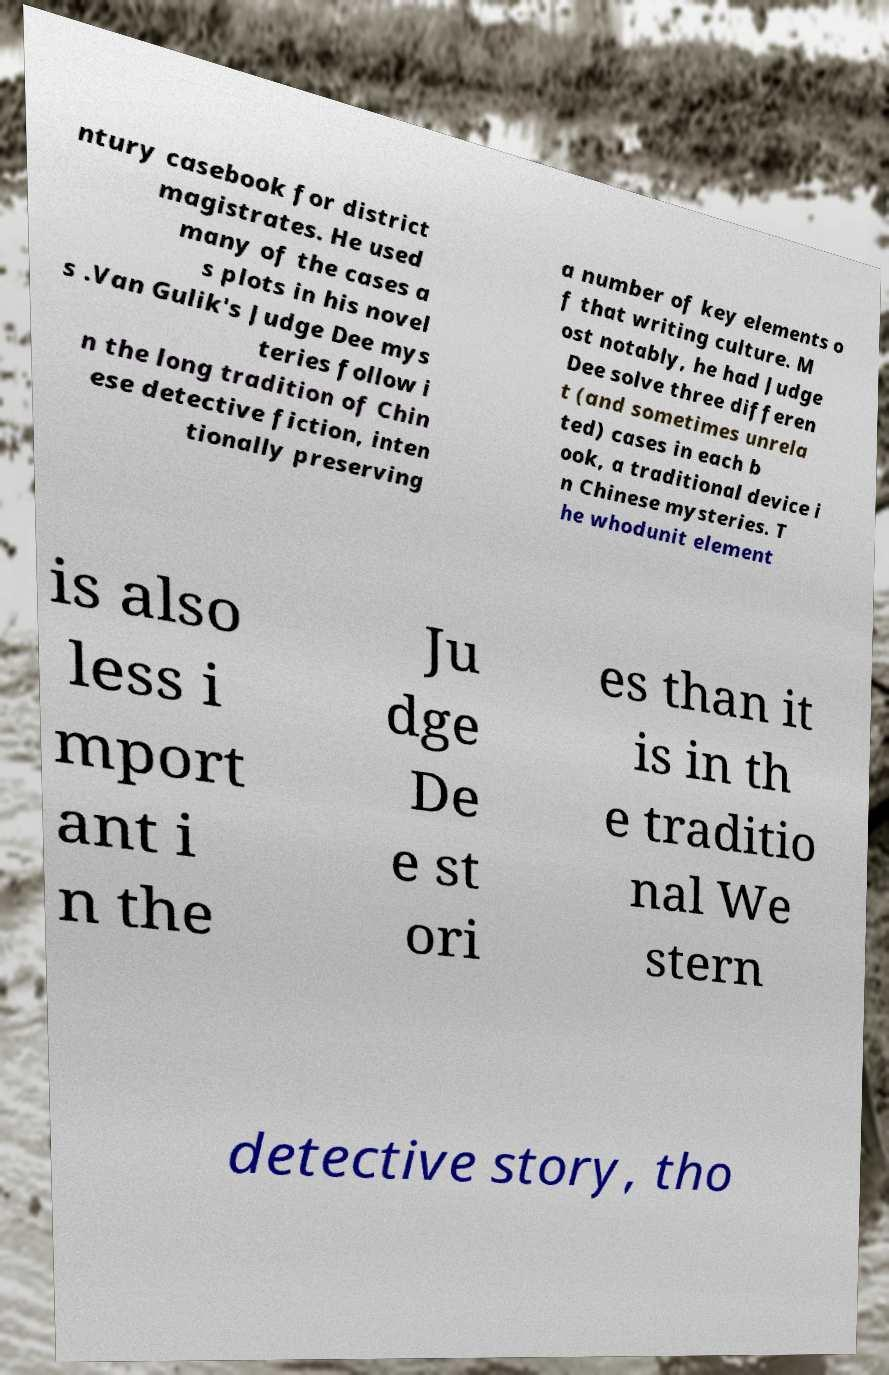Could you extract and type out the text from this image? ntury casebook for district magistrates. He used many of the cases a s plots in his novel s .Van Gulik's Judge Dee mys teries follow i n the long tradition of Chin ese detective fiction, inten tionally preserving a number of key elements o f that writing culture. M ost notably, he had Judge Dee solve three differen t (and sometimes unrela ted) cases in each b ook, a traditional device i n Chinese mysteries. T he whodunit element is also less i mport ant i n the Ju dge De e st ori es than it is in th e traditio nal We stern detective story, tho 